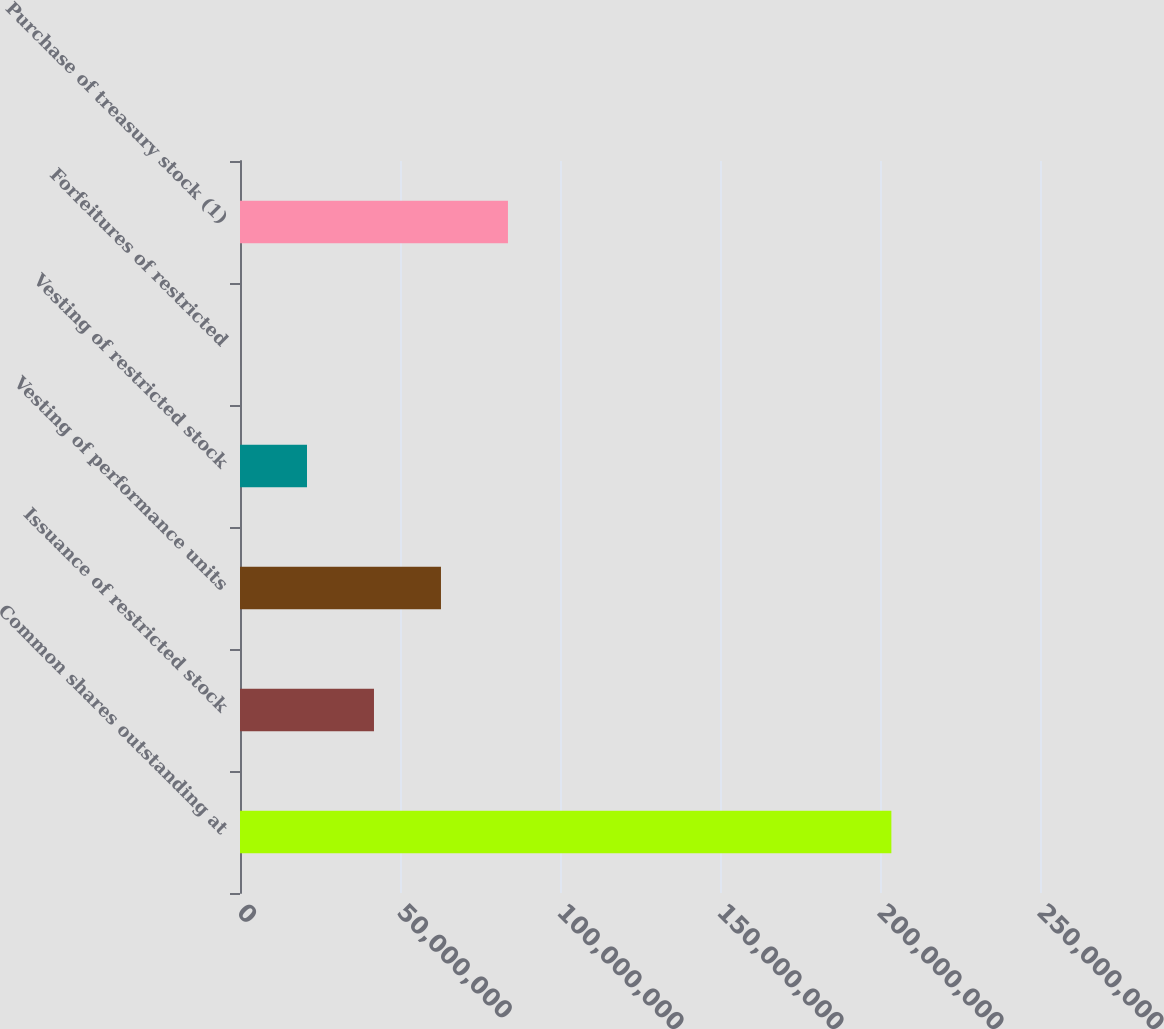<chart> <loc_0><loc_0><loc_500><loc_500><bar_chart><fcel>Common shares outstanding at<fcel>Issuance of restricted stock<fcel>Vesting of performance units<fcel>Vesting of restricted stock<fcel>Forfeitures of restricted<fcel>Purchase of treasury stock (1)<nl><fcel>2.03551e+08<fcel>4.18697e+07<fcel>6.28026e+07<fcel>2.09368e+07<fcel>3975<fcel>8.37354e+07<nl></chart> 